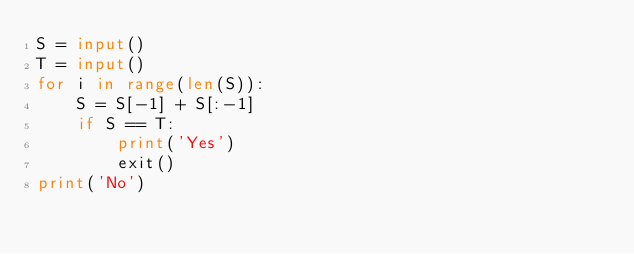<code> <loc_0><loc_0><loc_500><loc_500><_Python_>S = input()
T = input()
for i in range(len(S)):
    S = S[-1] + S[:-1]
    if S == T:
        print('Yes')
        exit()
print('No')</code> 